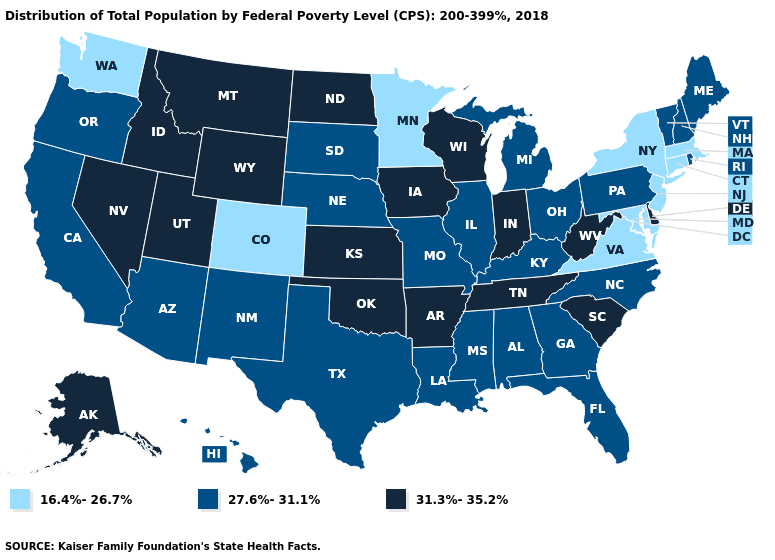Does the map have missing data?
Short answer required. No. Does New York have the lowest value in the Northeast?
Quick response, please. Yes. Does New Jersey have the lowest value in the Northeast?
Concise answer only. Yes. Among the states that border Oregon , which have the lowest value?
Write a very short answer. Washington. Does Texas have a higher value than Kentucky?
Short answer required. No. Does the map have missing data?
Write a very short answer. No. What is the value of West Virginia?
Concise answer only. 31.3%-35.2%. Name the states that have a value in the range 16.4%-26.7%?
Be succinct. Colorado, Connecticut, Maryland, Massachusetts, Minnesota, New Jersey, New York, Virginia, Washington. What is the value of Georgia?
Answer briefly. 27.6%-31.1%. Name the states that have a value in the range 16.4%-26.7%?
Concise answer only. Colorado, Connecticut, Maryland, Massachusetts, Minnesota, New Jersey, New York, Virginia, Washington. Among the states that border Kentucky , which have the lowest value?
Quick response, please. Virginia. What is the lowest value in the West?
Short answer required. 16.4%-26.7%. Does Missouri have the highest value in the MidWest?
Give a very brief answer. No. Does Massachusetts have the lowest value in the USA?
Short answer required. Yes. Does Nevada have the highest value in the USA?
Answer briefly. Yes. 